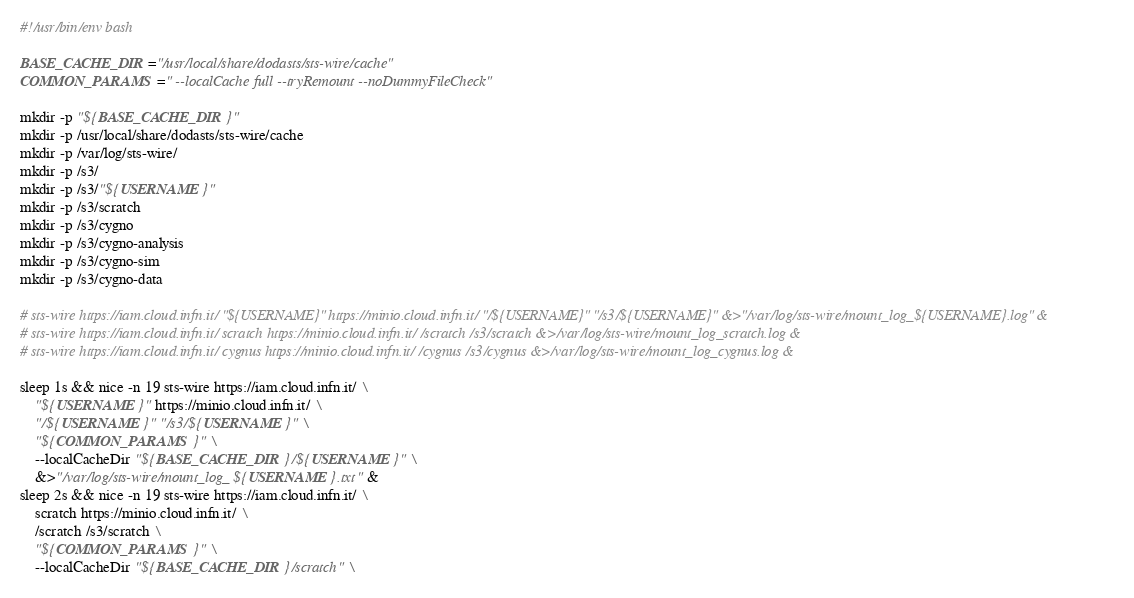<code> <loc_0><loc_0><loc_500><loc_500><_Bash_>#!/usr/bin/env bash

BASE_CACHE_DIR="/usr/local/share/dodasts/sts-wire/cache"
COMMON_PARAMS=" --localCache full --tryRemount --noDummyFileCheck"

mkdir -p "${BASE_CACHE_DIR}"
mkdir -p /usr/local/share/dodasts/sts-wire/cache
mkdir -p /var/log/sts-wire/
mkdir -p /s3/
mkdir -p /s3/"${USERNAME}"
mkdir -p /s3/scratch
mkdir -p /s3/cygno
mkdir -p /s3/cygno-analysis
mkdir -p /s3/cygno-sim
mkdir -p /s3/cygno-data

# sts-wire https://iam.cloud.infn.it/ "${USERNAME}" https://minio.cloud.infn.it/ "/${USERNAME}" "/s3/${USERNAME}" &>"/var/log/sts-wire/mount_log_${USERNAME}.log" &
# sts-wire https://iam.cloud.infn.it/ scratch https://minio.cloud.infn.it/ /scratch /s3/scratch &>/var/log/sts-wire/mount_log_scratch.log &
# sts-wire https://iam.cloud.infn.it/ cygnus https://minio.cloud.infn.it/ /cygnus /s3/cygnus &>/var/log/sts-wire/mount_log_cygnus.log &

sleep 1s && nice -n 19 sts-wire https://iam.cloud.infn.it/ \
    "${USERNAME}" https://minio.cloud.infn.it/ \
    "/${USERNAME}" "/s3/${USERNAME}" \
    "${COMMON_PARAMS}" \
    --localCacheDir "${BASE_CACHE_DIR}/${USERNAME}" \
    &>"/var/log/sts-wire/mount_log_${USERNAME}.txt" &
sleep 2s && nice -n 19 sts-wire https://iam.cloud.infn.it/ \
    scratch https://minio.cloud.infn.it/ \
    /scratch /s3/scratch \
    "${COMMON_PARAMS}" \
    --localCacheDir "${BASE_CACHE_DIR}/scratch" \</code> 